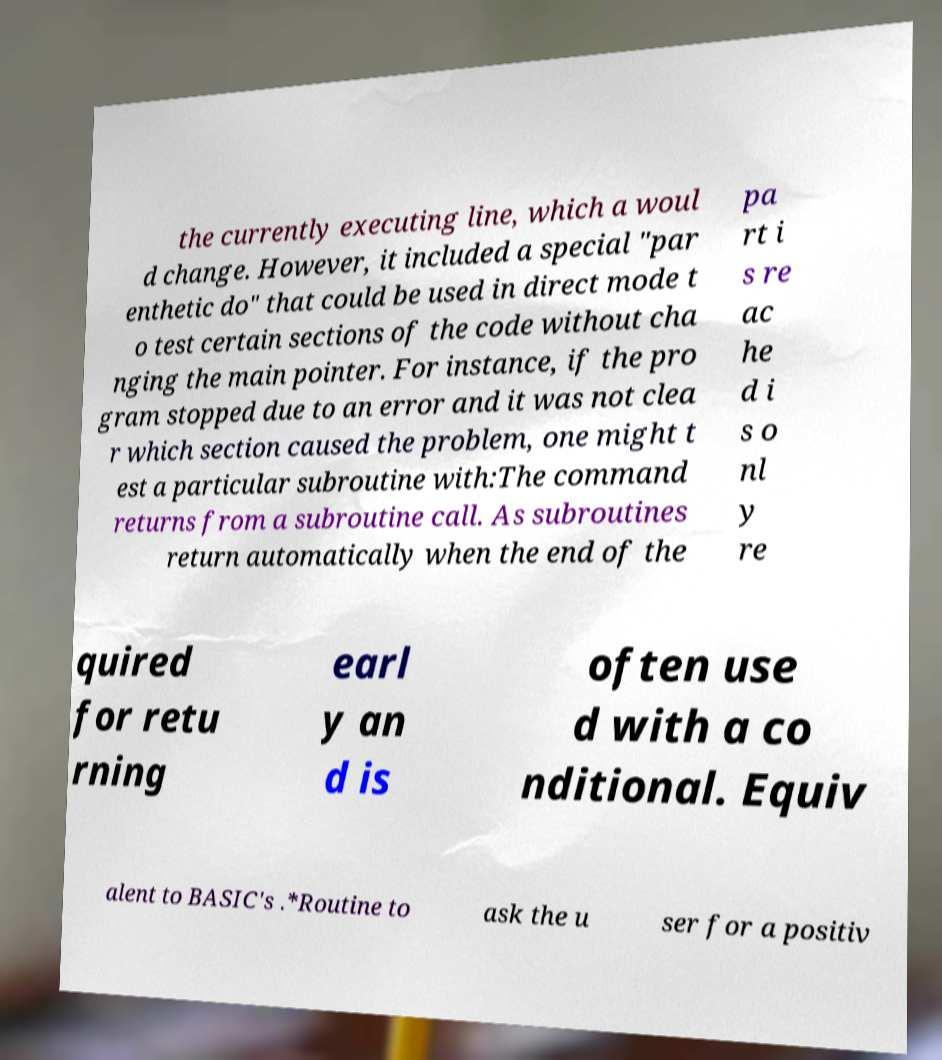For documentation purposes, I need the text within this image transcribed. Could you provide that? the currently executing line, which a woul d change. However, it included a special "par enthetic do" that could be used in direct mode t o test certain sections of the code without cha nging the main pointer. For instance, if the pro gram stopped due to an error and it was not clea r which section caused the problem, one might t est a particular subroutine with:The command returns from a subroutine call. As subroutines return automatically when the end of the pa rt i s re ac he d i s o nl y re quired for retu rning earl y an d is often use d with a co nditional. Equiv alent to BASIC's .*Routine to ask the u ser for a positiv 